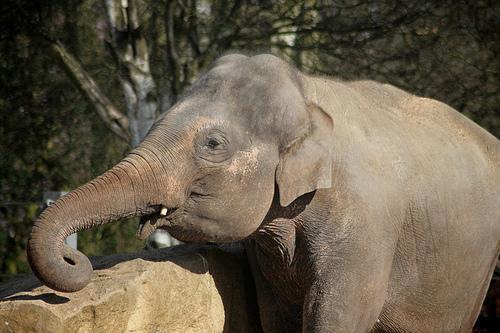How many elephants are there?
Give a very brief answer. 1. 